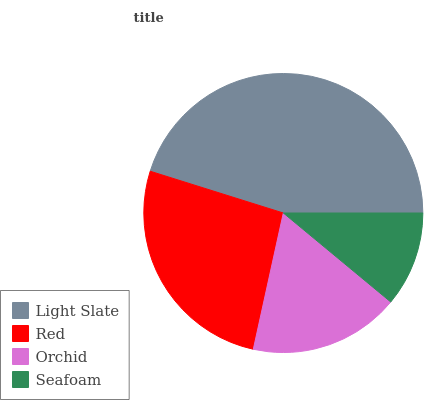Is Seafoam the minimum?
Answer yes or no. Yes. Is Light Slate the maximum?
Answer yes or no. Yes. Is Red the minimum?
Answer yes or no. No. Is Red the maximum?
Answer yes or no. No. Is Light Slate greater than Red?
Answer yes or no. Yes. Is Red less than Light Slate?
Answer yes or no. Yes. Is Red greater than Light Slate?
Answer yes or no. No. Is Light Slate less than Red?
Answer yes or no. No. Is Red the high median?
Answer yes or no. Yes. Is Orchid the low median?
Answer yes or no. Yes. Is Orchid the high median?
Answer yes or no. No. Is Red the low median?
Answer yes or no. No. 